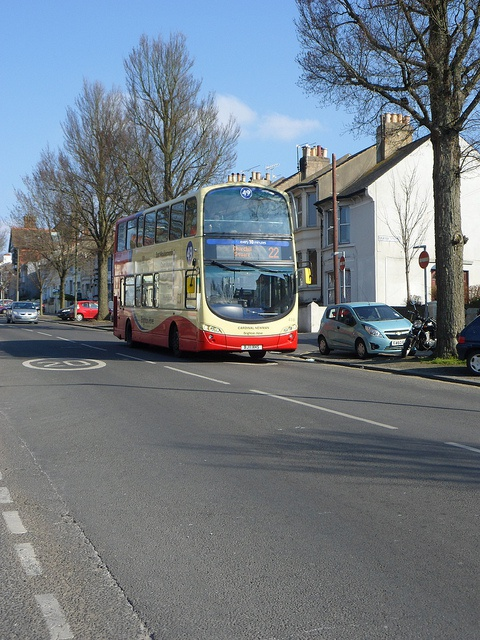Describe the objects in this image and their specific colors. I can see bus in lightblue, gray, black, and darkgray tones, car in lightblue, black, purple, and blue tones, car in lightblue, black, gray, and maroon tones, car in lightblue, gray, navy, and darkgray tones, and car in lightblue, black, salmon, gray, and red tones in this image. 